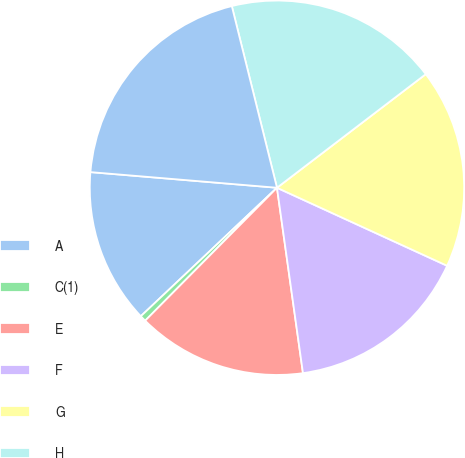Convert chart. <chart><loc_0><loc_0><loc_500><loc_500><pie_chart><fcel>A<fcel>C(1)<fcel>E<fcel>F<fcel>G<fcel>H<fcel>I<nl><fcel>13.37%<fcel>0.53%<fcel>14.65%<fcel>15.94%<fcel>17.22%<fcel>18.5%<fcel>19.79%<nl></chart> 